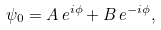<formula> <loc_0><loc_0><loc_500><loc_500>\psi _ { 0 } = A \, e ^ { i \phi } + B \, e ^ { - i \phi } ,</formula> 